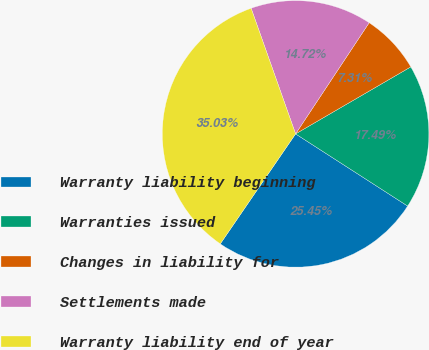<chart> <loc_0><loc_0><loc_500><loc_500><pie_chart><fcel>Warranty liability beginning<fcel>Warranties issued<fcel>Changes in liability for<fcel>Settlements made<fcel>Warranty liability end of year<nl><fcel>25.45%<fcel>17.49%<fcel>7.31%<fcel>14.72%<fcel>35.03%<nl></chart> 